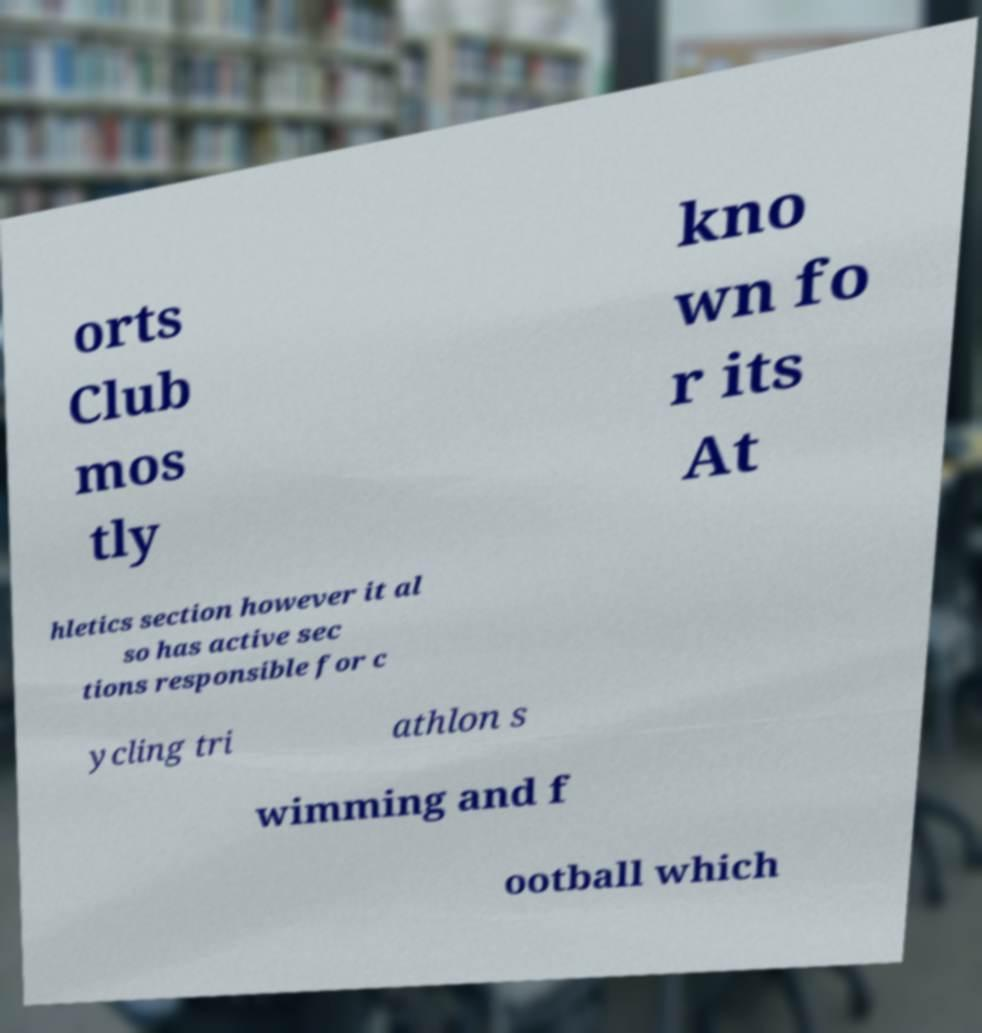There's text embedded in this image that I need extracted. Can you transcribe it verbatim? orts Club mos tly kno wn fo r its At hletics section however it al so has active sec tions responsible for c ycling tri athlon s wimming and f ootball which 